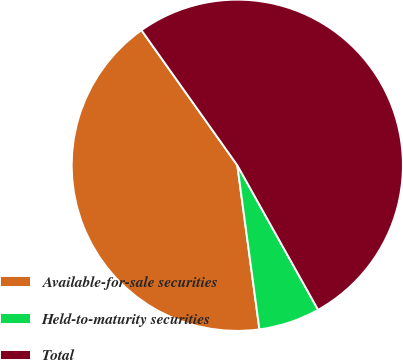<chart> <loc_0><loc_0><loc_500><loc_500><pie_chart><fcel>Available-for-sale securities<fcel>Held-to-maturity securities<fcel>Total<nl><fcel>42.31%<fcel>5.98%<fcel>51.71%<nl></chart> 